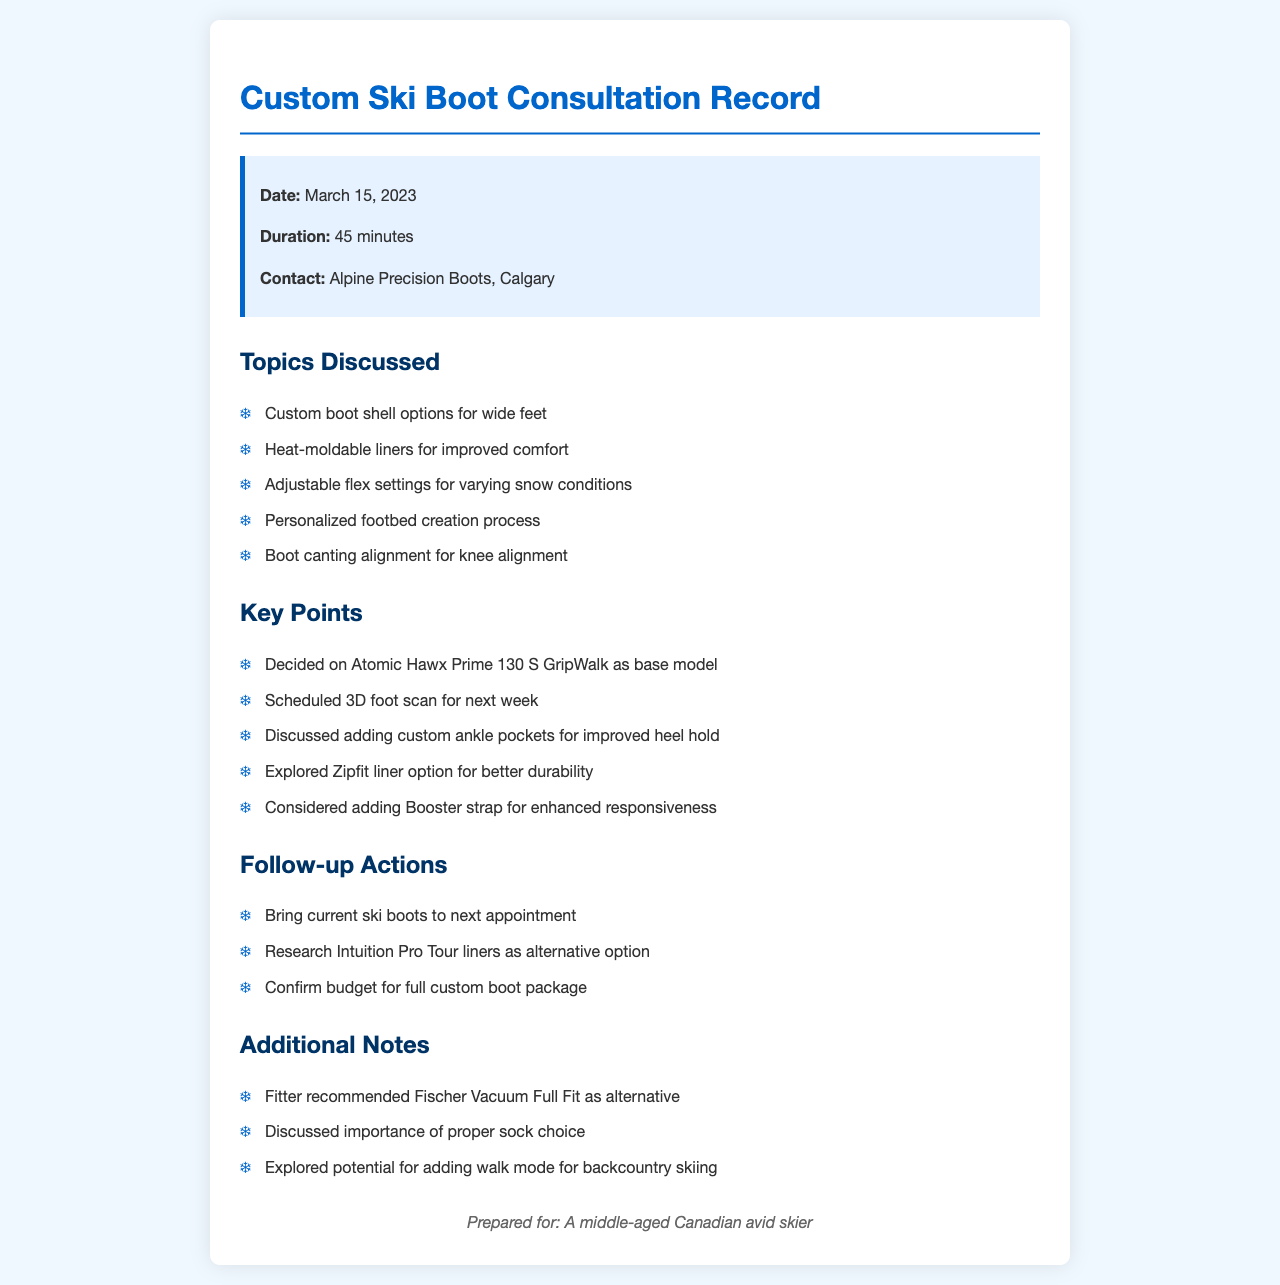What is the date of the consultation? The date of the consultation is specifically mentioned in the call info section of the document.
Answer: March 15, 2023 Who was contacted for the custom ski boot consultation? The contact information is provided in the call info section, indicating who was consulted.
Answer: Alpine Precision Boots, Calgary How long did the consultation last? The duration of the consultation is detailed in the call info section.
Answer: 45 minutes What base model was decided upon for the custom ski boot? The decision on the base model is clearly stated in the key points section.
Answer: Atomic Hawx Prime 130 S GripWalk What is a follow-up action to take to the next appointment? The follow-up actions include specific items to bring or research for the next meeting.
Answer: Bring current ski boots What was discussed regarding the boot fittings? The document lists different fitting adjustments and their purposes in the topics discussed section.
Answer: Custom ankle pockets What is one alternative liner that was explored? The key points section mentions different liner options discussed during the consultation.
Answer: Zipfit liner What additional feature was considered for backcountry skiing? The additional notes section highlights a potential feature for skiing purposes.
Answer: Walk mode What specific sock choice was emphasized? The importance of an item is highlighted in the additional notes section, which implies a recommendation.
Answer: Proper sock choice 